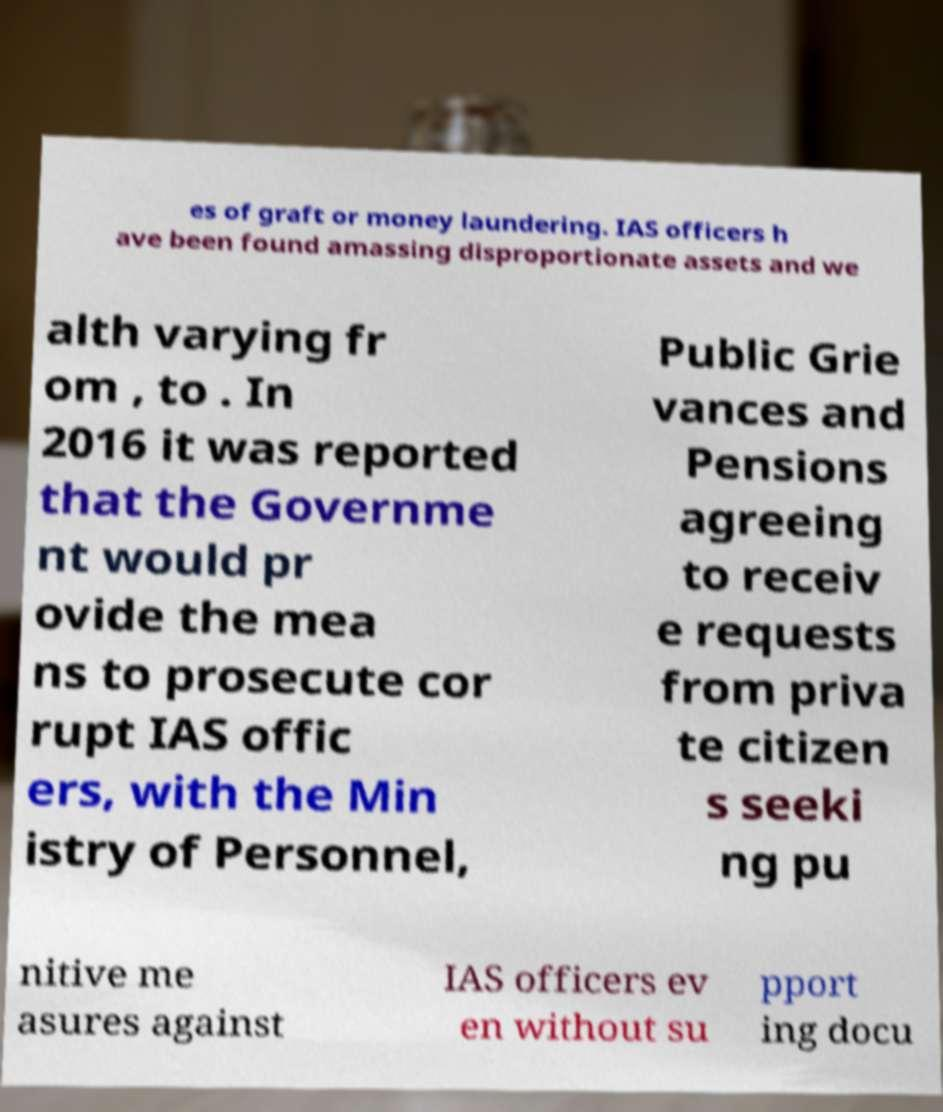Can you accurately transcribe the text from the provided image for me? es of graft or money laundering. IAS officers h ave been found amassing disproportionate assets and we alth varying fr om , to . In 2016 it was reported that the Governme nt would pr ovide the mea ns to prosecute cor rupt IAS offic ers, with the Min istry of Personnel, Public Grie vances and Pensions agreeing to receiv e requests from priva te citizen s seeki ng pu nitive me asures against IAS officers ev en without su pport ing docu 